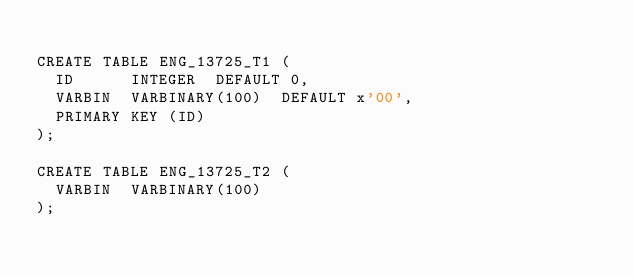<code> <loc_0><loc_0><loc_500><loc_500><_SQL_>
CREATE TABLE ENG_13725_T1 (
  ID      INTEGER  DEFAULT 0,
  VARBIN  VARBINARY(100)  DEFAULT x'00',
  PRIMARY KEY (ID)
);

CREATE TABLE ENG_13725_T2 (
  VARBIN  VARBINARY(100)
);
</code> 